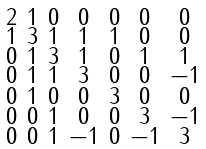<formula> <loc_0><loc_0><loc_500><loc_500>\begin{smallmatrix} 2 & 1 & 0 & 0 & 0 & 0 & 0 \\ 1 & 3 & 1 & 1 & 1 & 0 & 0 \\ 0 & 1 & 3 & 1 & 0 & 1 & 1 \\ 0 & 1 & 1 & 3 & 0 & 0 & - 1 \\ 0 & 1 & 0 & 0 & 3 & 0 & 0 \\ 0 & 0 & 1 & 0 & 0 & 3 & - 1 \\ 0 & 0 & 1 & - 1 & 0 & - 1 & 3 \end{smallmatrix}</formula> 